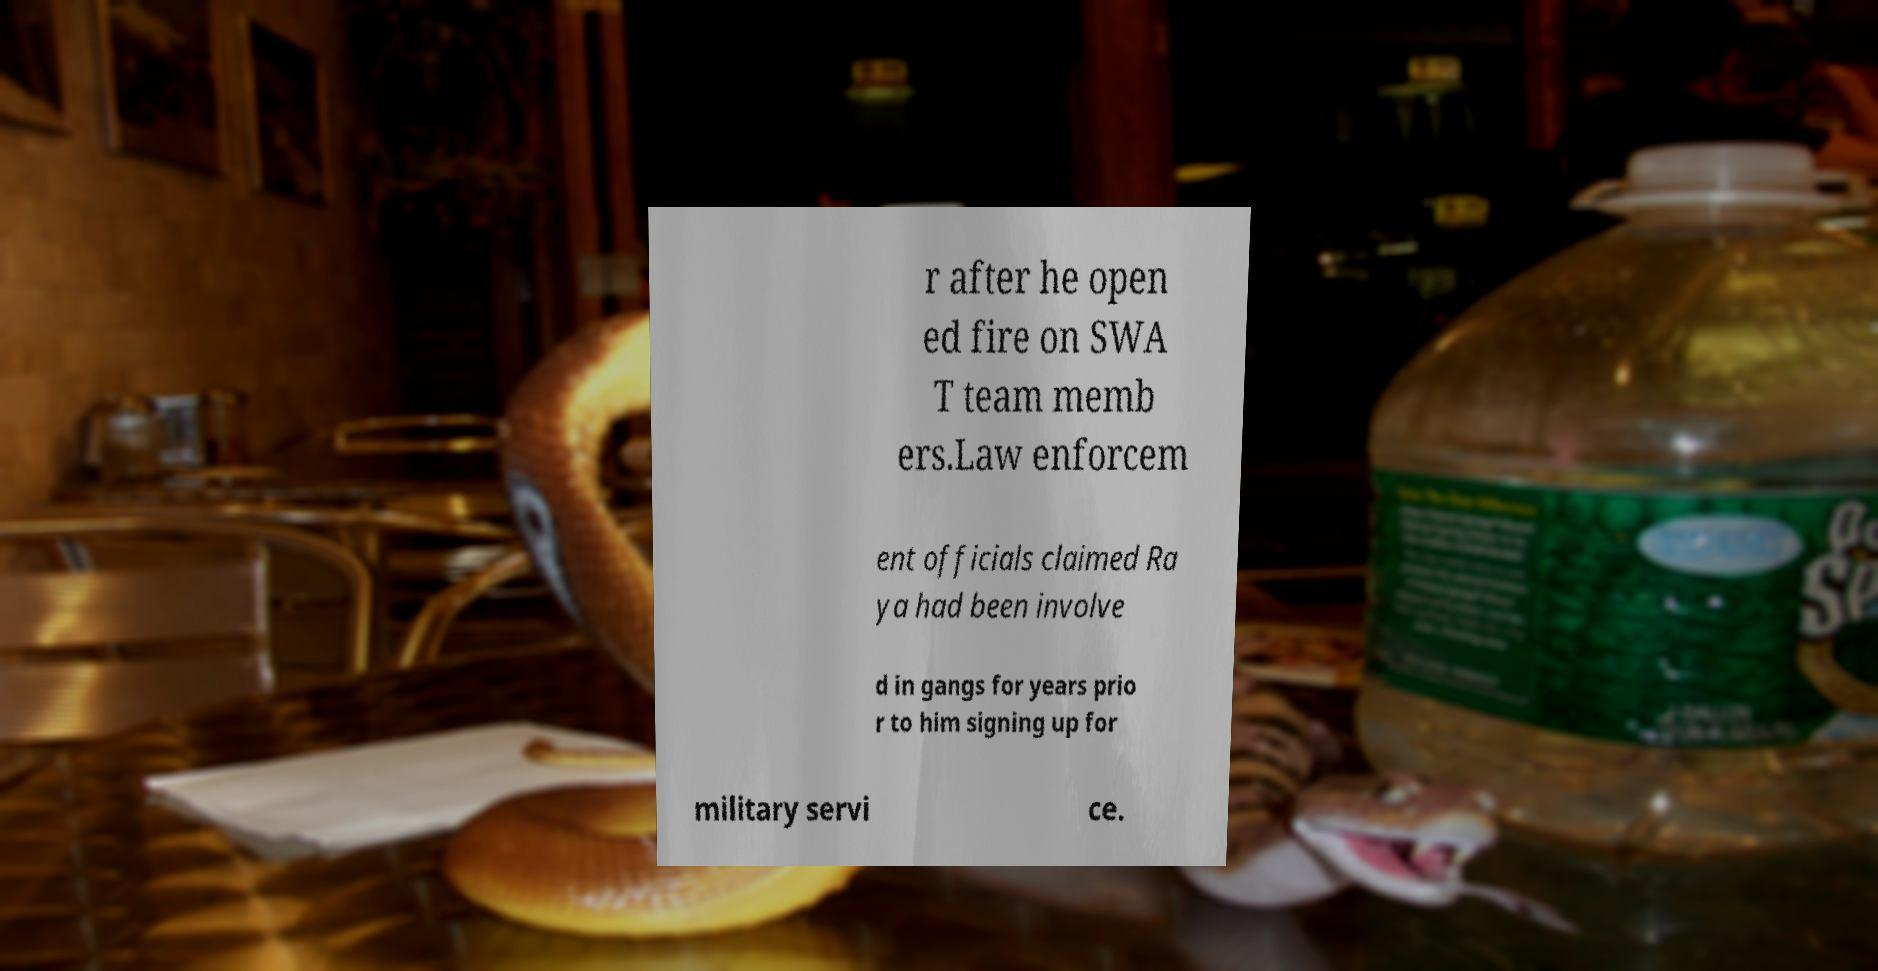Can you accurately transcribe the text from the provided image for me? r after he open ed fire on SWA T team memb ers.Law enforcem ent officials claimed Ra ya had been involve d in gangs for years prio r to him signing up for military servi ce. 